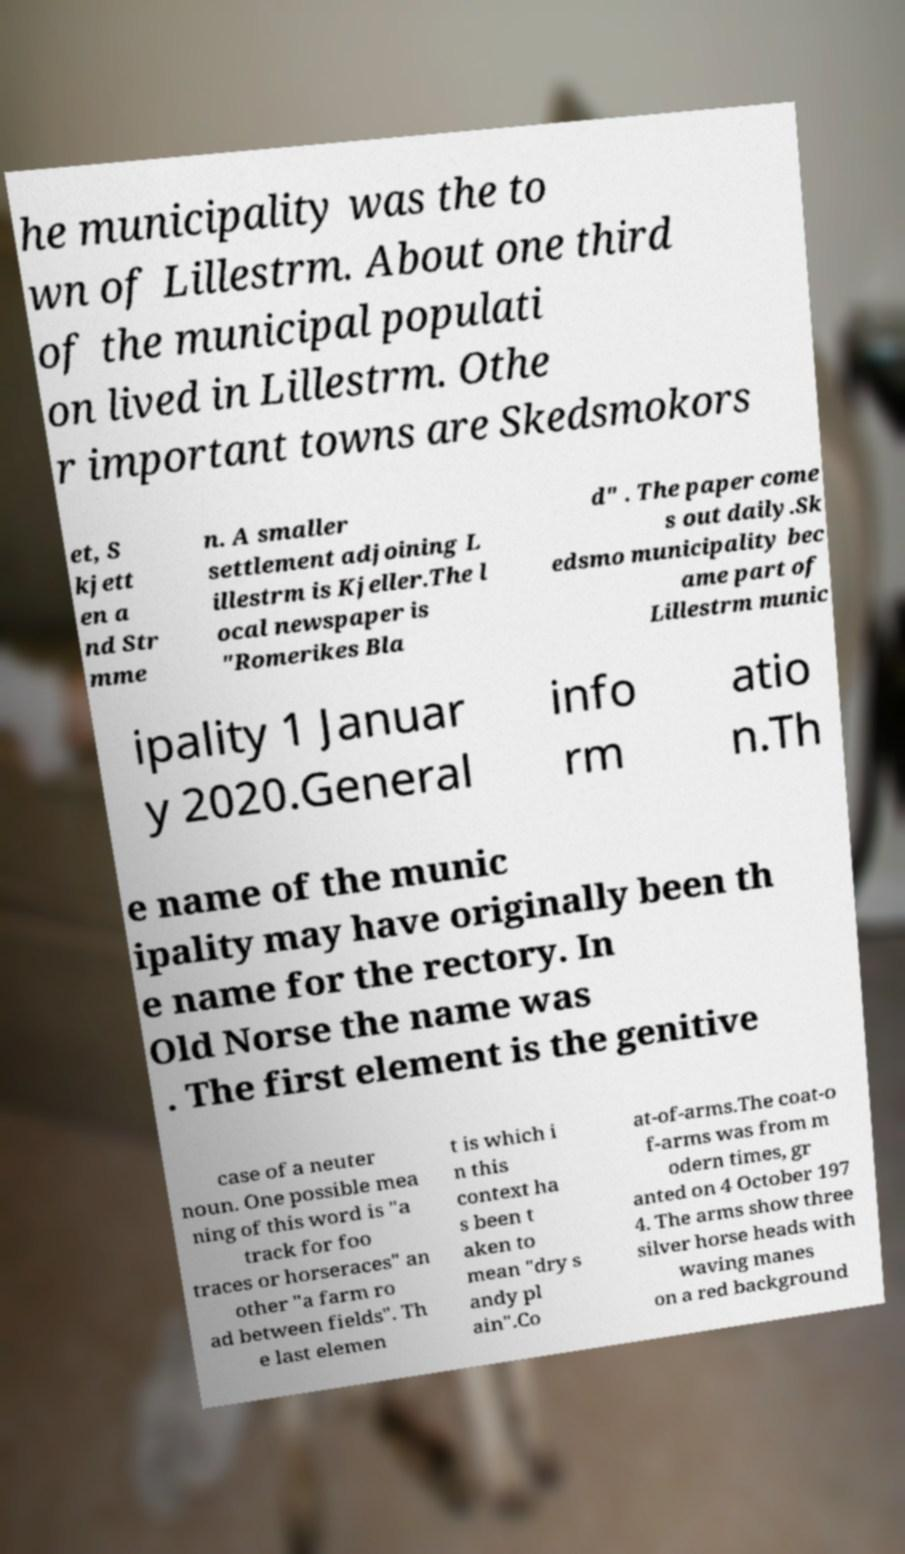Can you accurately transcribe the text from the provided image for me? he municipality was the to wn of Lillestrm. About one third of the municipal populati on lived in Lillestrm. Othe r important towns are Skedsmokors et, S kjett en a nd Str mme n. A smaller settlement adjoining L illestrm is Kjeller.The l ocal newspaper is "Romerikes Bla d" . The paper come s out daily.Sk edsmo municipality bec ame part of Lillestrm munic ipality 1 Januar y 2020.General info rm atio n.Th e name of the munic ipality may have originally been th e name for the rectory. In Old Norse the name was . The first element is the genitive case of a neuter noun. One possible mea ning of this word is "a track for foo traces or horseraces" an other "a farm ro ad between fields". Th e last elemen t is which i n this context ha s been t aken to mean "dry s andy pl ain".Co at-of-arms.The coat-o f-arms was from m odern times, gr anted on 4 October 197 4. The arms show three silver horse heads with waving manes on a red background 